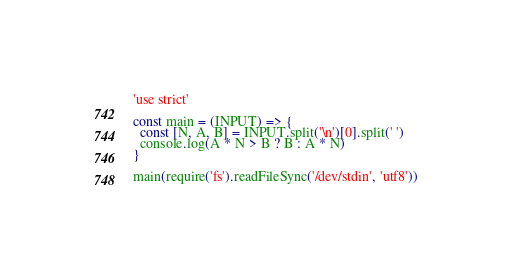<code> <loc_0><loc_0><loc_500><loc_500><_JavaScript_>'use strict'

const main = (INPUT) => {
  const [N, A, B] = INPUT.split('\n')[0].split(' ')
  console.log(A * N > B ? B : A * N)
}

main(require('fs').readFileSync('/dev/stdin', 'utf8'))
</code> 